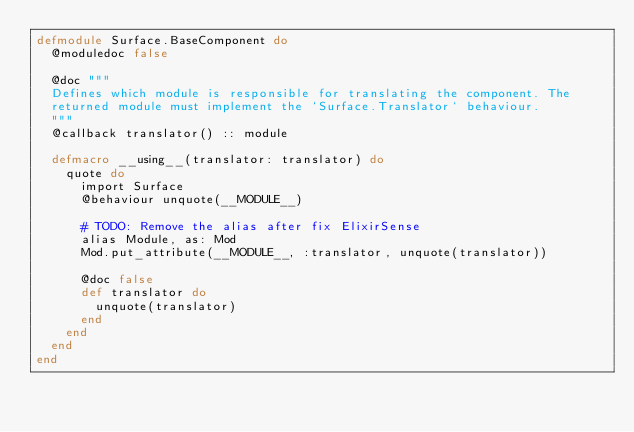Convert code to text. <code><loc_0><loc_0><loc_500><loc_500><_Elixir_>defmodule Surface.BaseComponent do
  @moduledoc false

  @doc """
  Defines which module is responsible for translating the component. The
  returned module must implement the `Surface.Translator` behaviour.
  """
  @callback translator() :: module

  defmacro __using__(translator: translator) do
    quote do
      import Surface
      @behaviour unquote(__MODULE__)

      # TODO: Remove the alias after fix ElixirSense
      alias Module, as: Mod
      Mod.put_attribute(__MODULE__, :translator, unquote(translator))

      @doc false
      def translator do
        unquote(translator)
      end
    end
  end
end
</code> 